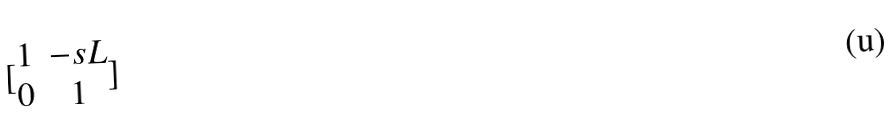<formula> <loc_0><loc_0><loc_500><loc_500>[ \begin{matrix} 1 & - s L \\ 0 & 1 \end{matrix} ]</formula> 